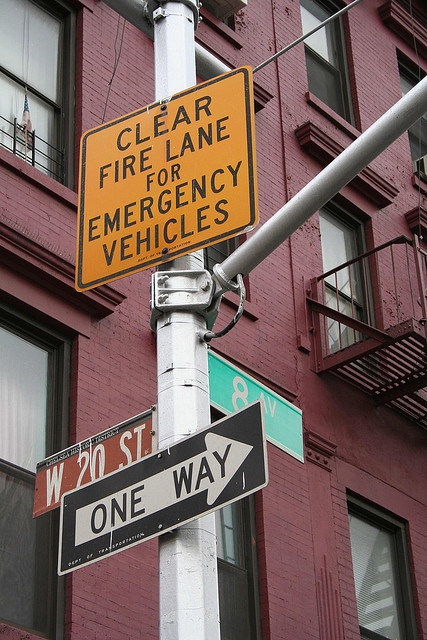Describe the objects in this image and their specific colors. I can see various objects in this image with different colors. 